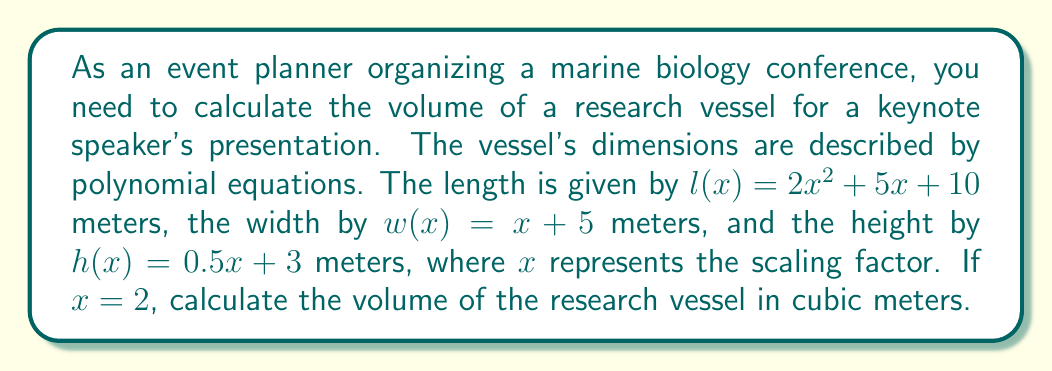Provide a solution to this math problem. To calculate the volume of the research vessel, we need to multiply the length, width, and height functions evaluated at $x = 2$. Let's solve this step-by-step:

1. Calculate the length $l(2)$:
   $$l(2) = 2(2)^2 + 5(2) + 10 = 2(4) + 10 + 10 = 8 + 10 + 10 = 28$$
   The length is 28 meters.

2. Calculate the width $w(2)$:
   $$w(2) = 2 + 5 = 7$$
   The width is 7 meters.

3. Calculate the height $h(2)$:
   $$h(2) = 0.5(2) + 3 = 1 + 3 = 4$$
   The height is 4 meters.

4. Now, we can calculate the volume by multiplying these dimensions:
   $$V = l(2) \times w(2) \times h(2) = 28 \times 7 \times 4 = 784$$

Therefore, the volume of the research vessel is 784 cubic meters.
Answer: 784 cubic meters 